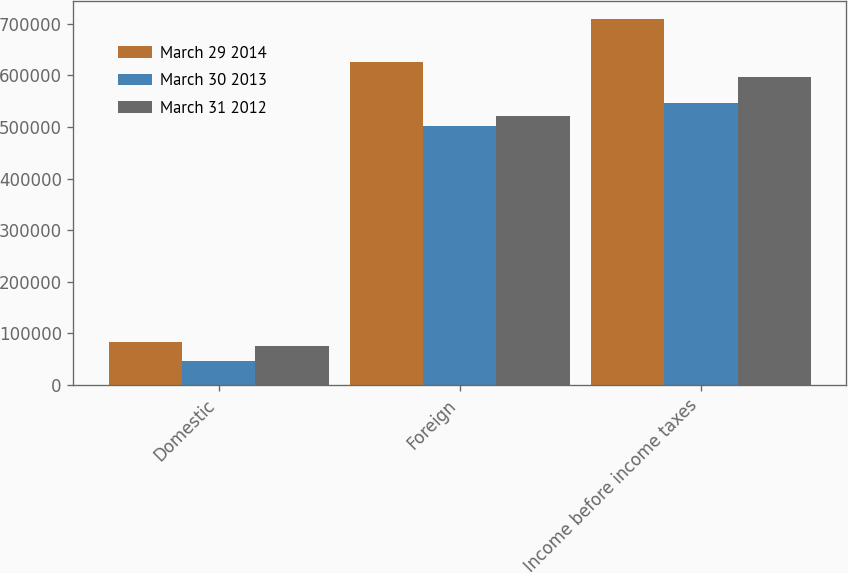Convert chart. <chart><loc_0><loc_0><loc_500><loc_500><stacked_bar_chart><ecel><fcel>Domestic<fcel>Foreign<fcel>Income before income taxes<nl><fcel>March 29 2014<fcel>83617<fcel>625909<fcel>709526<nl><fcel>March 30 2013<fcel>45617<fcel>501389<fcel>547006<nl><fcel>March 31 2012<fcel>74959<fcel>522092<fcel>597051<nl></chart> 